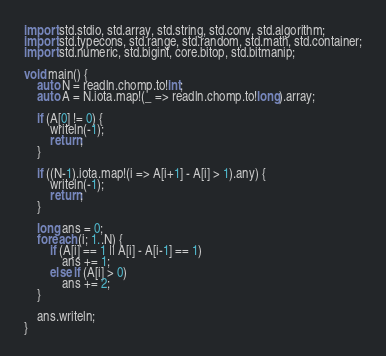<code> <loc_0><loc_0><loc_500><loc_500><_D_>import std.stdio, std.array, std.string, std.conv, std.algorithm;
import std.typecons, std.range, std.random, std.math, std.container;
import std.numeric, std.bigint, core.bitop, std.bitmanip;

void main() {
    auto N = readln.chomp.to!int;
    auto A = N.iota.map!(_ => readln.chomp.to!long).array;

    if (A[0] != 0) {
        writeln(-1);
        return;
    }

    if ((N-1).iota.map!(i => A[i+1] - A[i] > 1).any) {
        writeln(-1);
        return;
    }

    long ans = 0;
    foreach (i; 1..N) {
        if (A[i] == 1 || A[i] - A[i-1] == 1)
            ans += 1;
        else if (A[i] > 0)
            ans += 2;
    }

    ans.writeln;
}
</code> 